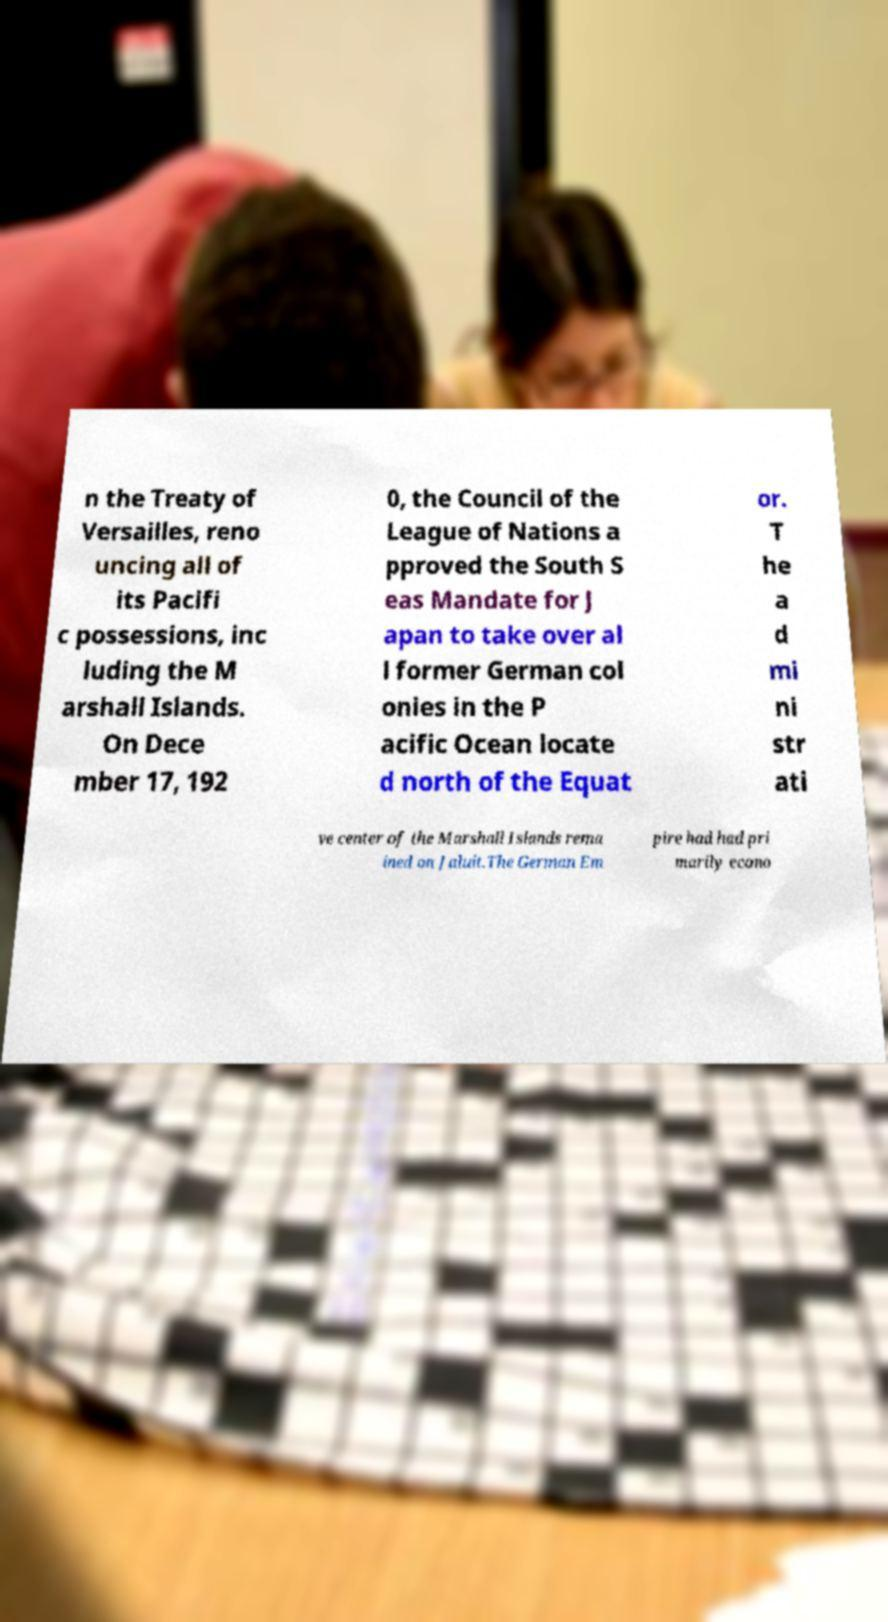Can you read and provide the text displayed in the image?This photo seems to have some interesting text. Can you extract and type it out for me? n the Treaty of Versailles, reno uncing all of its Pacifi c possessions, inc luding the M arshall Islands. On Dece mber 17, 192 0, the Council of the League of Nations a pproved the South S eas Mandate for J apan to take over al l former German col onies in the P acific Ocean locate d north of the Equat or. T he a d mi ni str ati ve center of the Marshall Islands rema ined on Jaluit.The German Em pire had had pri marily econo 